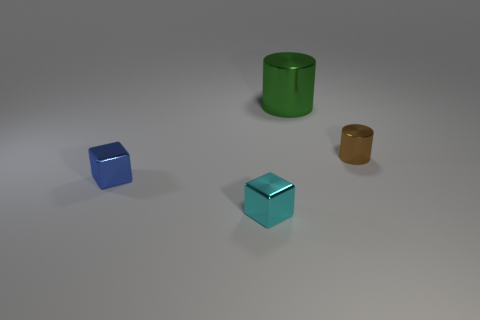What material is the cyan thing?
Your response must be concise. Metal. What color is the small cube that is behind the small cyan cube?
Give a very brief answer. Blue. What number of shiny blocks are the same color as the big metallic thing?
Provide a short and direct response. 0. What number of metallic things are on the right side of the large green thing and in front of the small blue metal cube?
Keep it short and to the point. 0. There is a blue metallic object that is the same size as the brown cylinder; what is its shape?
Ensure brevity in your answer.  Cube. What size is the brown metal object?
Keep it short and to the point. Small. The other small cube that is the same material as the tiny blue block is what color?
Give a very brief answer. Cyan. There is a cylinder in front of the metallic cylinder that is to the left of the brown metal cylinder; how many big green objects are in front of it?
Your answer should be very brief. 0. How many things are small shiny objects that are on the left side of the brown cylinder or large yellow rubber spheres?
Provide a short and direct response. 2. There is a object behind the tiny metallic object that is behind the small blue metal object; what is its shape?
Your answer should be very brief. Cylinder. 